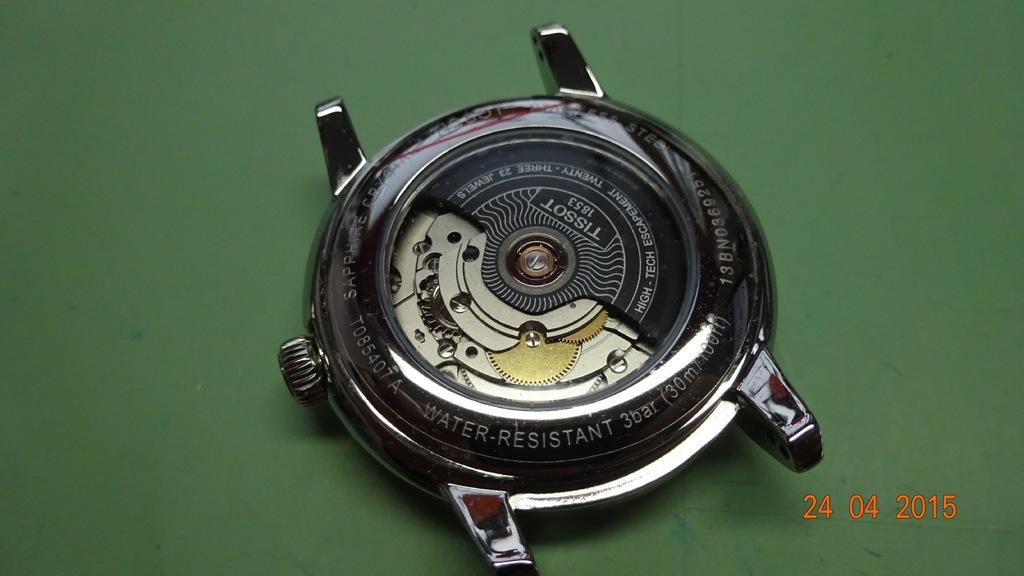How deep is this watch water resistant to?
Offer a very short reply. 30m. What year was this photo taken?
Offer a very short reply. 2015. 